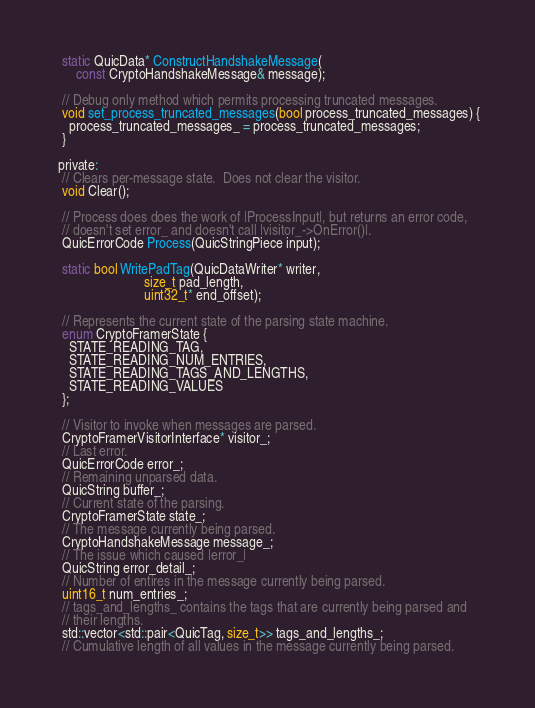Convert code to text. <code><loc_0><loc_0><loc_500><loc_500><_C_>  static QuicData* ConstructHandshakeMessage(
      const CryptoHandshakeMessage& message);

  // Debug only method which permits processing truncated messages.
  void set_process_truncated_messages(bool process_truncated_messages) {
    process_truncated_messages_ = process_truncated_messages;
  }

 private:
  // Clears per-message state.  Does not clear the visitor.
  void Clear();

  // Process does does the work of |ProcessInput|, but returns an error code,
  // doesn't set error_ and doesn't call |visitor_->OnError()|.
  QuicErrorCode Process(QuicStringPiece input);

  static bool WritePadTag(QuicDataWriter* writer,
                          size_t pad_length,
                          uint32_t* end_offset);

  // Represents the current state of the parsing state machine.
  enum CryptoFramerState {
    STATE_READING_TAG,
    STATE_READING_NUM_ENTRIES,
    STATE_READING_TAGS_AND_LENGTHS,
    STATE_READING_VALUES
  };

  // Visitor to invoke when messages are parsed.
  CryptoFramerVisitorInterface* visitor_;
  // Last error.
  QuicErrorCode error_;
  // Remaining unparsed data.
  QuicString buffer_;
  // Current state of the parsing.
  CryptoFramerState state_;
  // The message currently being parsed.
  CryptoHandshakeMessage message_;
  // The issue which caused |error_|
  QuicString error_detail_;
  // Number of entires in the message currently being parsed.
  uint16_t num_entries_;
  // tags_and_lengths_ contains the tags that are currently being parsed and
  // their lengths.
  std::vector<std::pair<QuicTag, size_t>> tags_and_lengths_;
  // Cumulative length of all values in the message currently being parsed.</code> 